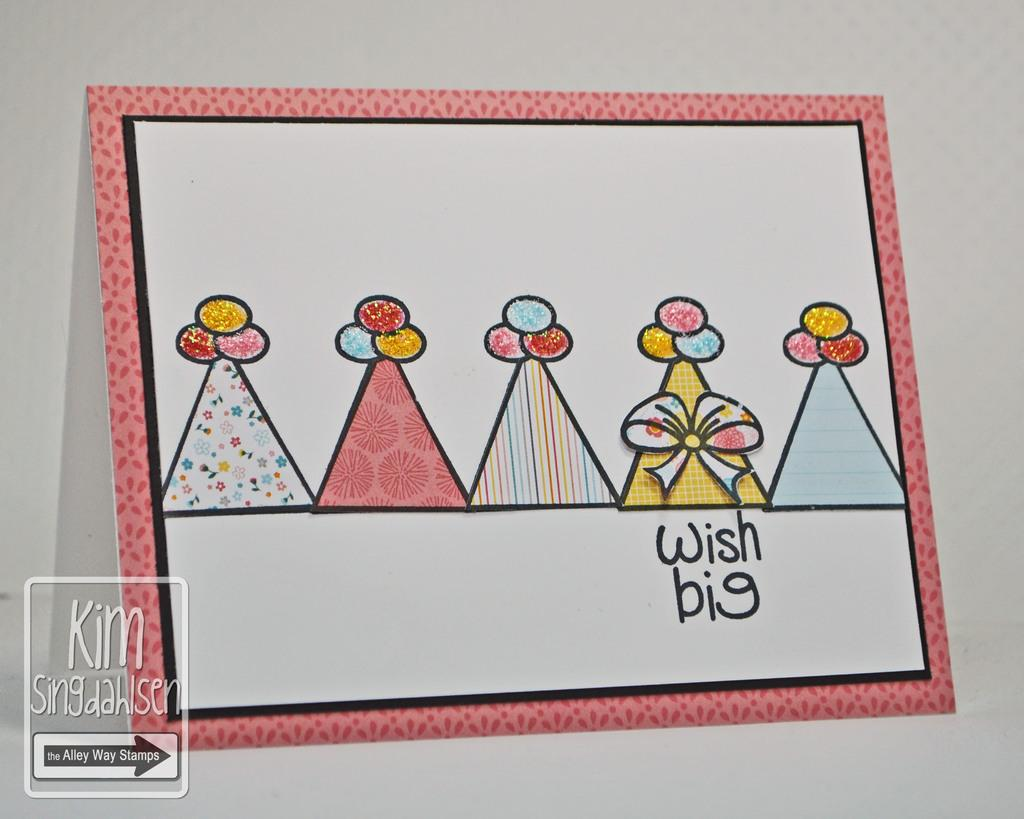<image>
Write a terse but informative summary of the picture. A card with five party hats and the words wish big on it. 